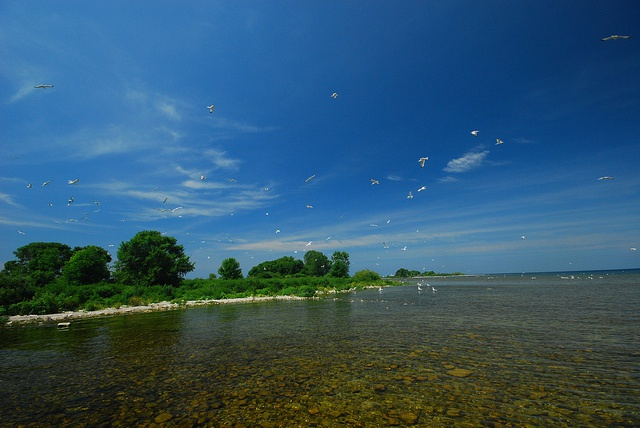Describe the objects in this image and their specific colors. I can see bird in gray and darkgray tones, bird in gray, navy, black, and blue tones, bird in gray, blue, and darkgray tones, bird in gray, darkblue, and blue tones, and bird in gray, purple, and darkgray tones in this image. 